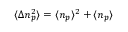<formula> <loc_0><loc_0><loc_500><loc_500>\langle \Delta n _ { p } ^ { 2 } \rangle = \langle n _ { p } \rangle ^ { 2 } + \langle n _ { p } \rangle</formula> 